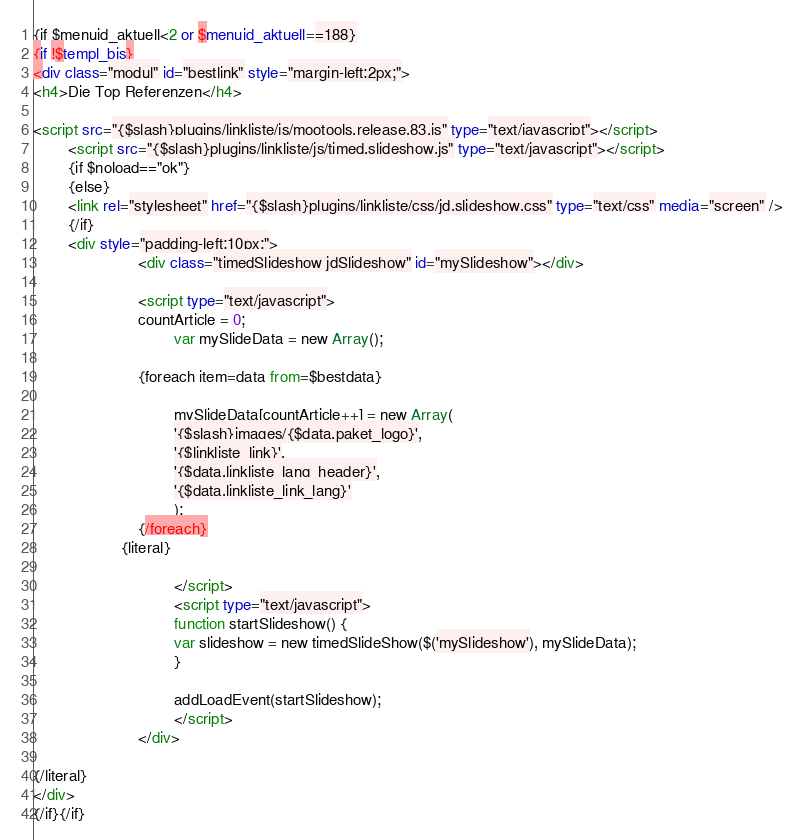Convert code to text. <code><loc_0><loc_0><loc_500><loc_500><_HTML_>{if $menuid_aktuell<2 or $menuid_aktuell==188}
{if !$templ_bis}
<div class="modul" id="bestlink" style="margin-left:2px;">
<h4>Die Top Referenzen</h4>

<script src="{$slash}plugins/linkliste/js/mootools.release.83.js" type="text/javascript"></script>
        <script src="{$slash}plugins/linkliste/js/timed.slideshow.js" type="text/javascript"></script>
        {if $noload=="ok"}
		{else}
		<link rel="stylesheet" href="{$slash}plugins/linkliste/css/jd.slideshow.css" type="text/css" media="screen" />
		{/if}
		<div style="padding-left:10px;">
                        <div class="timedSlideshow jdSlideshow" id="mySlideshow"></div>
						
                        <script type="text/javascript">
						countArticle = 0;
								var mySlideData = new Array();
						
						{foreach item=data from=$bestdata}
						
								mySlideData[countArticle++] = new Array(
								'{$slash}images/{$data.paket_logo}',
								'{$linkliste_link}',
								'{$data.linkliste_lang_header}',
								'{$data.linkliste_link_lang}'
								);
						{/foreach}
					{literal}
								
								</script>
								<script type="text/javascript">
								function startSlideshow() {
								var slideshow = new timedSlideShow($('mySlideshow'), mySlideData);
								}

								addLoadEvent(startSlideshow);
								</script>
						</div>
              
{/literal} 
</div>
{/if}{/if}</code> 